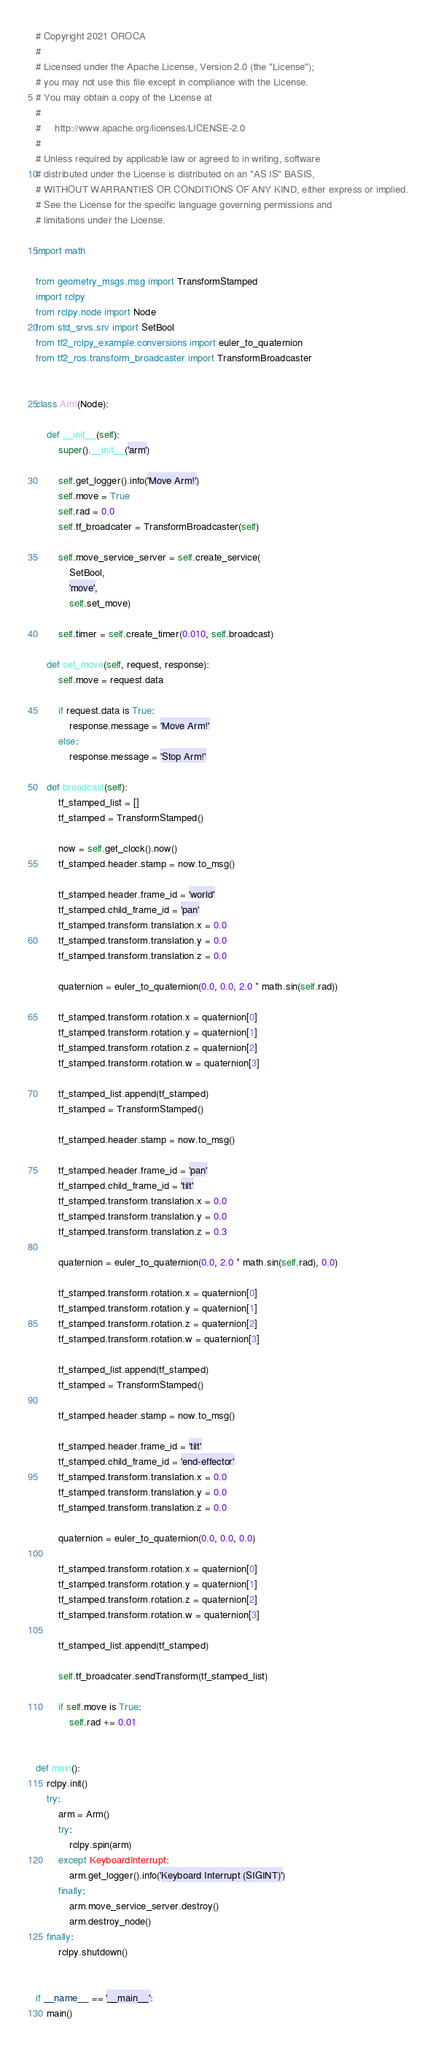Convert code to text. <code><loc_0><loc_0><loc_500><loc_500><_Python_># Copyright 2021 OROCA
#
# Licensed under the Apache License, Version 2.0 (the "License");
# you may not use this file except in compliance with the License.
# You may obtain a copy of the License at
#
#     http://www.apache.org/licenses/LICENSE-2.0
#
# Unless required by applicable law or agreed to in writing, software
# distributed under the License is distributed on an "AS IS" BASIS,
# WITHOUT WARRANTIES OR CONDITIONS OF ANY KIND, either express or implied.
# See the License for the specific language governing permissions and
# limitations under the License.

import math

from geometry_msgs.msg import TransformStamped
import rclpy
from rclpy.node import Node
from std_srvs.srv import SetBool
from tf2_rclpy_example.conversions import euler_to_quaternion
from tf2_ros.transform_broadcaster import TransformBroadcaster


class Arm(Node):

    def __init__(self):
        super().__init__('arm')

        self.get_logger().info('Move Arm!')
        self.move = True
        self.rad = 0.0
        self.tf_broadcater = TransformBroadcaster(self)

        self.move_service_server = self.create_service(
            SetBool,
            'move',
            self.set_move)

        self.timer = self.create_timer(0.010, self.broadcast)

    def set_move(self, request, response):
        self.move = request.data

        if request.data is True:
            response.message = 'Move Arm!'
        else:
            response.message = 'Stop Arm!'

    def broadcast(self):
        tf_stamped_list = []
        tf_stamped = TransformStamped()

        now = self.get_clock().now()
        tf_stamped.header.stamp = now.to_msg()

        tf_stamped.header.frame_id = 'world'
        tf_stamped.child_frame_id = 'pan'
        tf_stamped.transform.translation.x = 0.0
        tf_stamped.transform.translation.y = 0.0
        tf_stamped.transform.translation.z = 0.0

        quaternion = euler_to_quaternion(0.0, 0.0, 2.0 * math.sin(self.rad))

        tf_stamped.transform.rotation.x = quaternion[0]
        tf_stamped.transform.rotation.y = quaternion[1]
        tf_stamped.transform.rotation.z = quaternion[2]
        tf_stamped.transform.rotation.w = quaternion[3]

        tf_stamped_list.append(tf_stamped)
        tf_stamped = TransformStamped()

        tf_stamped.header.stamp = now.to_msg()

        tf_stamped.header.frame_id = 'pan'
        tf_stamped.child_frame_id = 'tilt'
        tf_stamped.transform.translation.x = 0.0
        tf_stamped.transform.translation.y = 0.0
        tf_stamped.transform.translation.z = 0.3

        quaternion = euler_to_quaternion(0.0, 2.0 * math.sin(self.rad), 0.0)

        tf_stamped.transform.rotation.x = quaternion[0]
        tf_stamped.transform.rotation.y = quaternion[1]
        tf_stamped.transform.rotation.z = quaternion[2]
        tf_stamped.transform.rotation.w = quaternion[3]

        tf_stamped_list.append(tf_stamped)
        tf_stamped = TransformStamped()

        tf_stamped.header.stamp = now.to_msg()

        tf_stamped.header.frame_id = 'tilt'
        tf_stamped.child_frame_id = 'end-effector'
        tf_stamped.transform.translation.x = 0.0
        tf_stamped.transform.translation.y = 0.0
        tf_stamped.transform.translation.z = 0.0

        quaternion = euler_to_quaternion(0.0, 0.0, 0.0)

        tf_stamped.transform.rotation.x = quaternion[0]
        tf_stamped.transform.rotation.y = quaternion[1]
        tf_stamped.transform.rotation.z = quaternion[2]
        tf_stamped.transform.rotation.w = quaternion[3]

        tf_stamped_list.append(tf_stamped)

        self.tf_broadcater.sendTransform(tf_stamped_list)

        if self.move is True:
            self.rad += 0.01


def main():
    rclpy.init()
    try:
        arm = Arm()
        try:
            rclpy.spin(arm)
        except KeyboardInterrupt:
            arm.get_logger().info('Keyboard Interrupt (SIGINT)')
        finally:
            arm.move_service_server.destroy()
            arm.destroy_node()
    finally:
        rclpy.shutdown()


if __name__ == '__main__':
    main()
</code> 